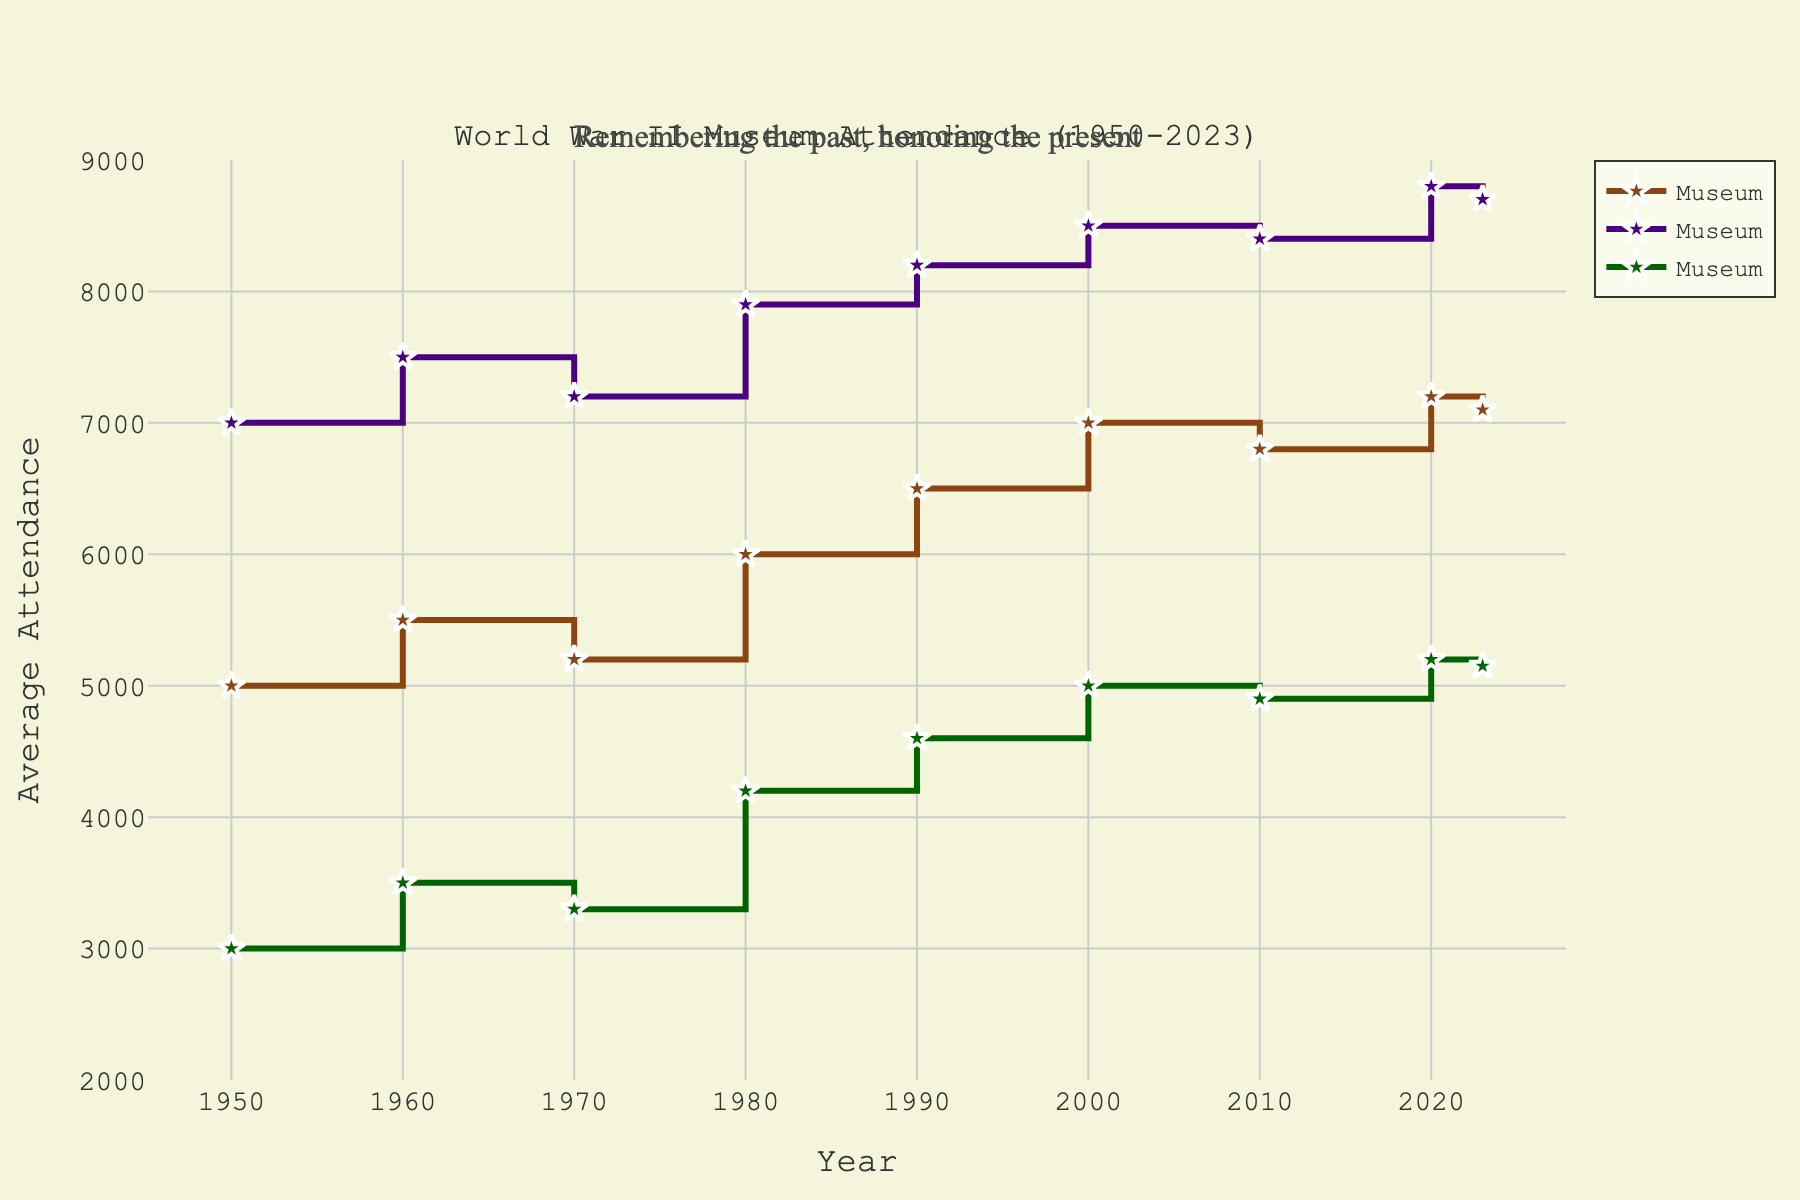what is the title of the figure? The title of the figure is located at the top and it indicates the subject of the plot.
Answer: World War II Museum Attendance (1950-2023) How many museums are presented in the plot? The plot shows three separate lines, each labeled with a different museum name.
Answer: Three What is the general trend of public interest over time in Museum B? By observing the line for Museum B, we see that it generally increases with small variations throughout the years.
Answer: Increasing In which year did Museum C show the least average attendance? Looking at the line for Museum C, the lowest point can be traced back to the year 1950.
Answer: 1950 How does the attendance in Museum A in 2020 compare to that in 2010? By comparing the y-values for Museum A in both years, we see that the attendance in 2020 (7200) is higher than in 2010 (6800).
Answer: Higher Which museum had the highest attendance in 2023? Observing the endpoints of each line in the year 2023, Museum B has the highest y-value.
Answer: Museum B What is the difference in attendance between Museum A and Museum B in the year 2000? The plot shows that Museum A had an attendance of 7000 and Museum B had 8500 in 2000. Calculating the difference: 8500 - 7000 = 1500.
Answer: 1500 Which museum showed a noticeable dip in attendance, and in which decade did it occur? Museum A shows a noticeable dip in the attendance line between 2000 and 2010.
Answer: Museum A, 2010s By how much did Museum C's attendance increase from 1950 to 1990? The attendance for Museum C in 1950 was 3000, and in 1990 it was 4600. The increase is 4600 - 3000 = 1600.
Answer: 1600 What is the average attendance for Museum B over the 70 years from 1950 to 2020? The values for Museum B over the specified years are [7000, 7500, 7200, 7900, 8200, 8500, 8400, 8800]. Summing them up: 7000+7500+7200+7900+8200+8500+8400+8800 = 63000. Dividing by the number of values: 63000/8 = 7875.
Answer: 7875 